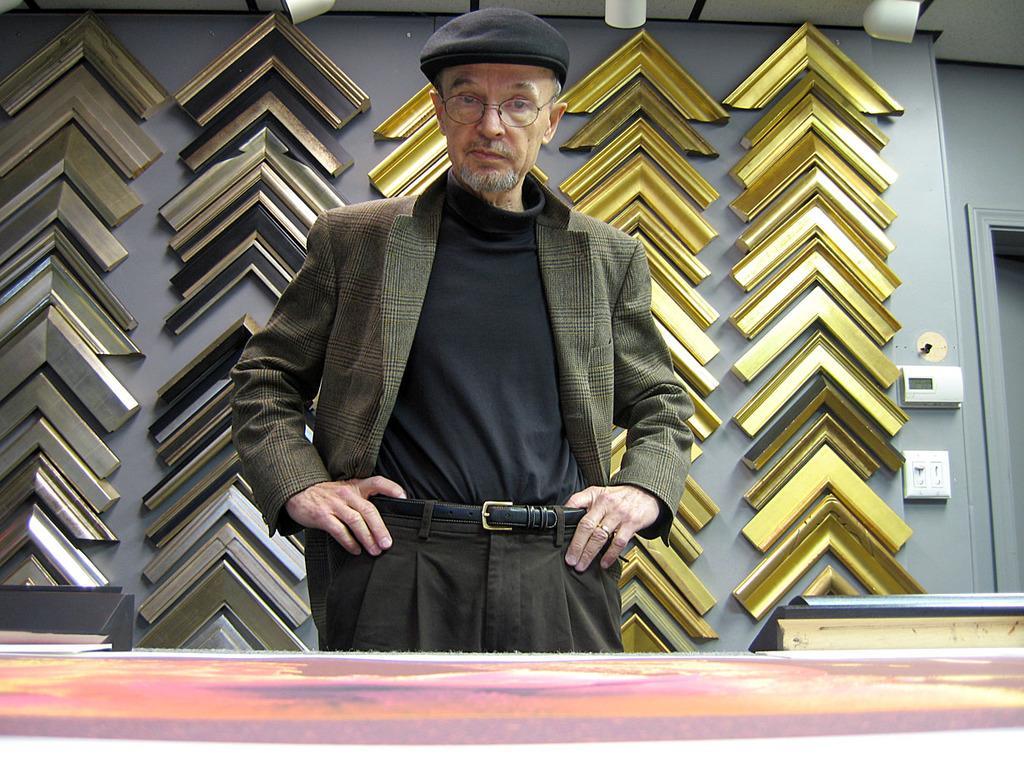How would you summarize this image in a sentence or two? In this image there is a person wearing blazer and belt. He is standing behind the table having few objects on it. He is wearing spectacles and a cap. Behind him there is wall having wooden frames attached to it. 